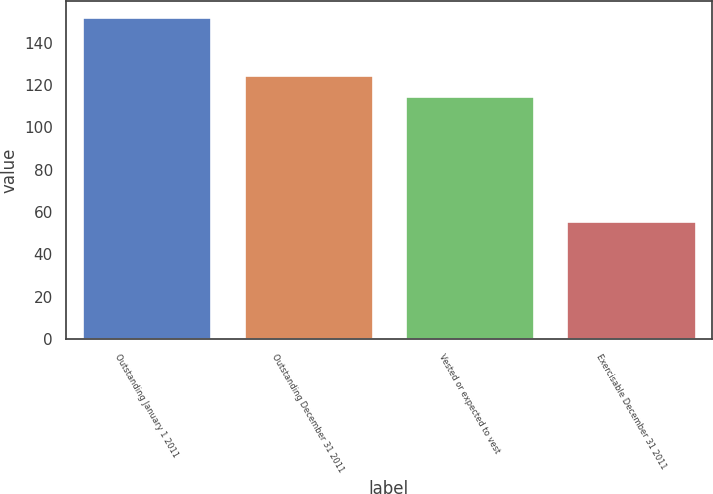Convert chart. <chart><loc_0><loc_0><loc_500><loc_500><bar_chart><fcel>Outstanding January 1 2011<fcel>Outstanding December 31 2011<fcel>Vested or expected to vest<fcel>Exercisable December 31 2011<nl><fcel>152<fcel>124.6<fcel>115<fcel>56<nl></chart> 